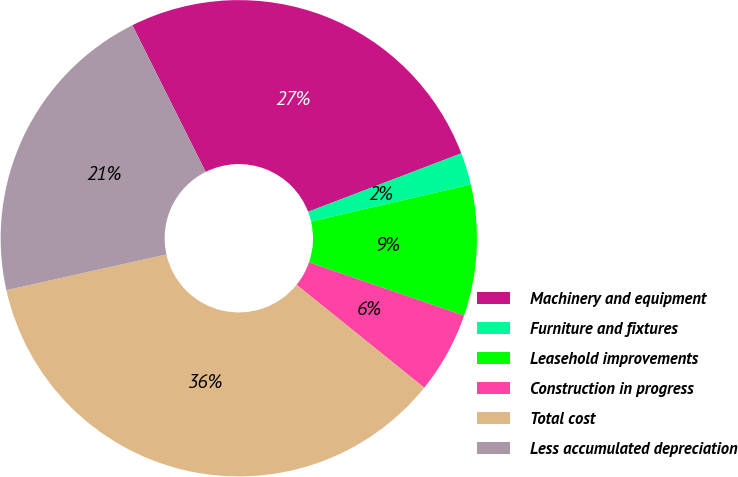<chart> <loc_0><loc_0><loc_500><loc_500><pie_chart><fcel>Machinery and equipment<fcel>Furniture and fixtures<fcel>Leasehold improvements<fcel>Construction in progress<fcel>Total cost<fcel>Less accumulated depreciation<nl><fcel>26.57%<fcel>2.18%<fcel>8.89%<fcel>5.53%<fcel>35.7%<fcel>21.12%<nl></chart> 